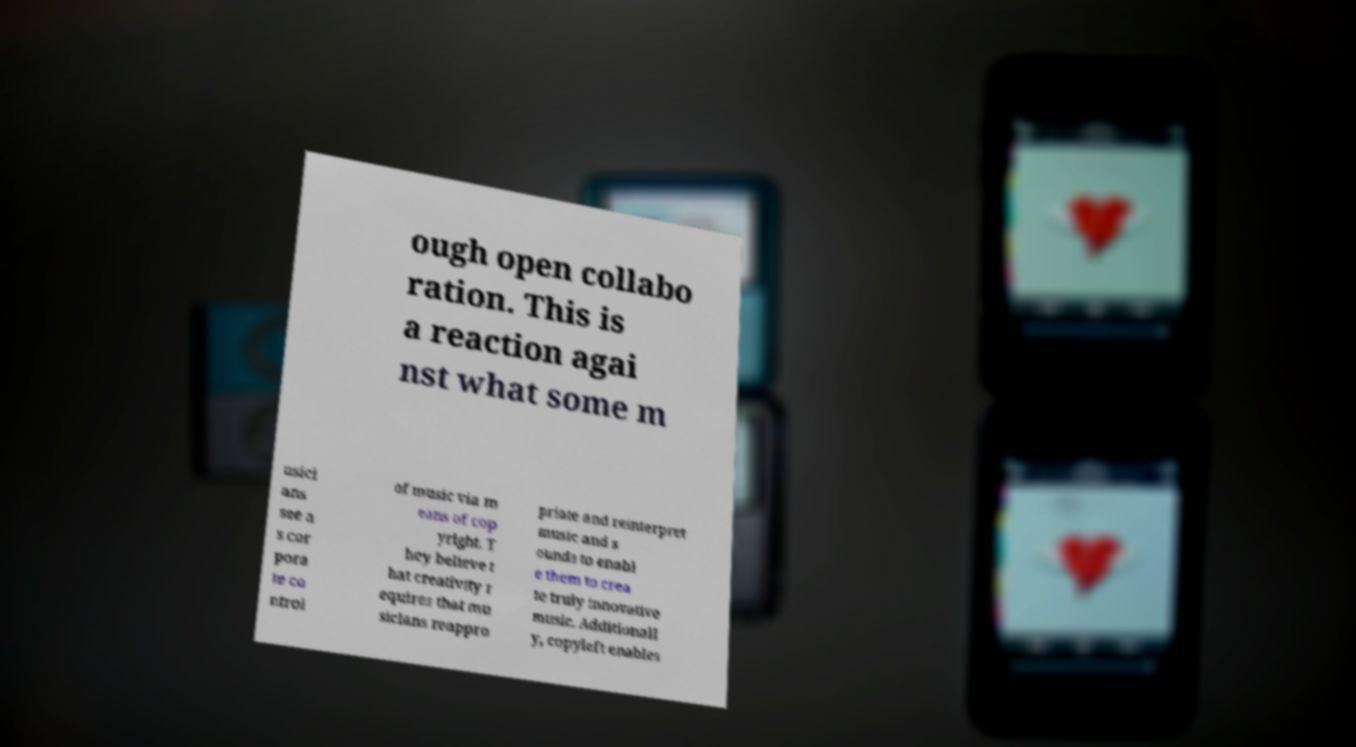Can you read and provide the text displayed in the image?This photo seems to have some interesting text. Can you extract and type it out for me? ough open collabo ration. This is a reaction agai nst what some m usici ans see a s cor pora te co ntrol of music via m eans of cop yright. T hey believe t hat creativity r equires that mu sicians reappro priate and reinterpret music and s ounds to enabl e them to crea te truly innovative music. Additionall y, copyleft enables 